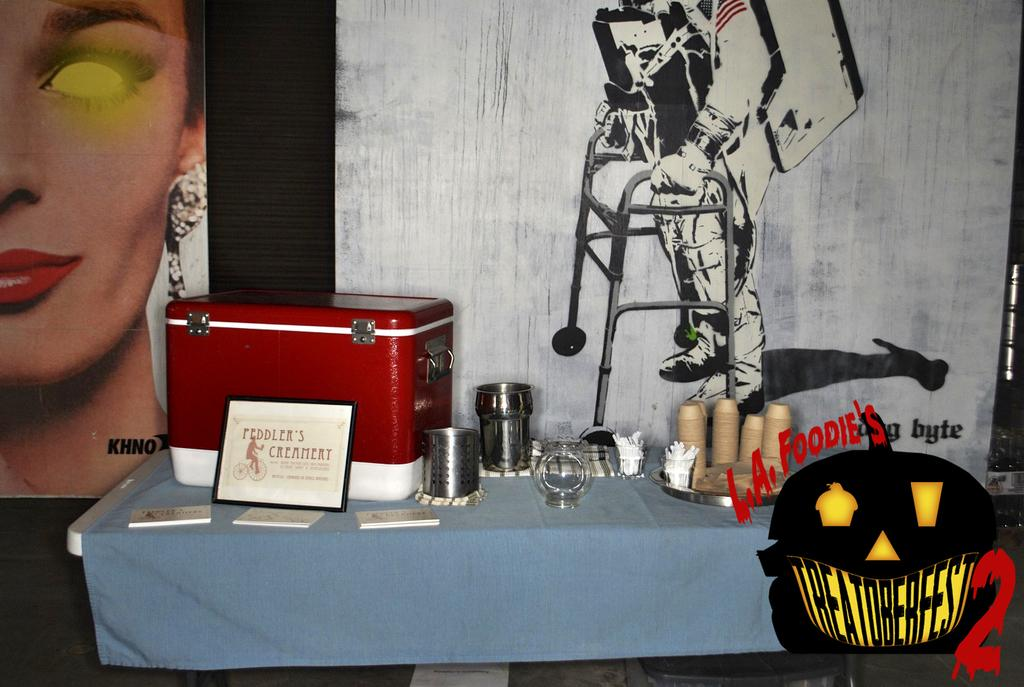<image>
Create a compact narrative representing the image presented. An advertisement for L.A. Foodie's 2 written in red. 